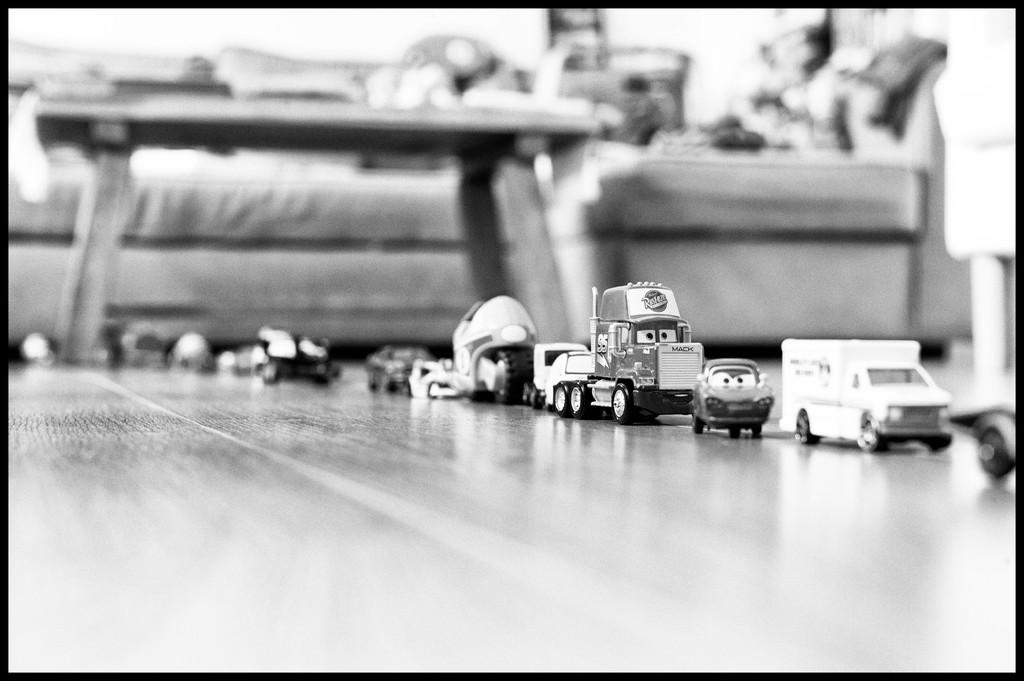What is the color scheme of the image? The image is black and white. What types of toys are on the floor in the image? There are car and truck toys on the floor. What piece of furniture is in the image? There is a sofa in the image. What is located in front of the sofa? There is a table in front of the sofa. What type of pie is being served on the table in the image? There is no pie present in the image; it only features a table and a sofa. 